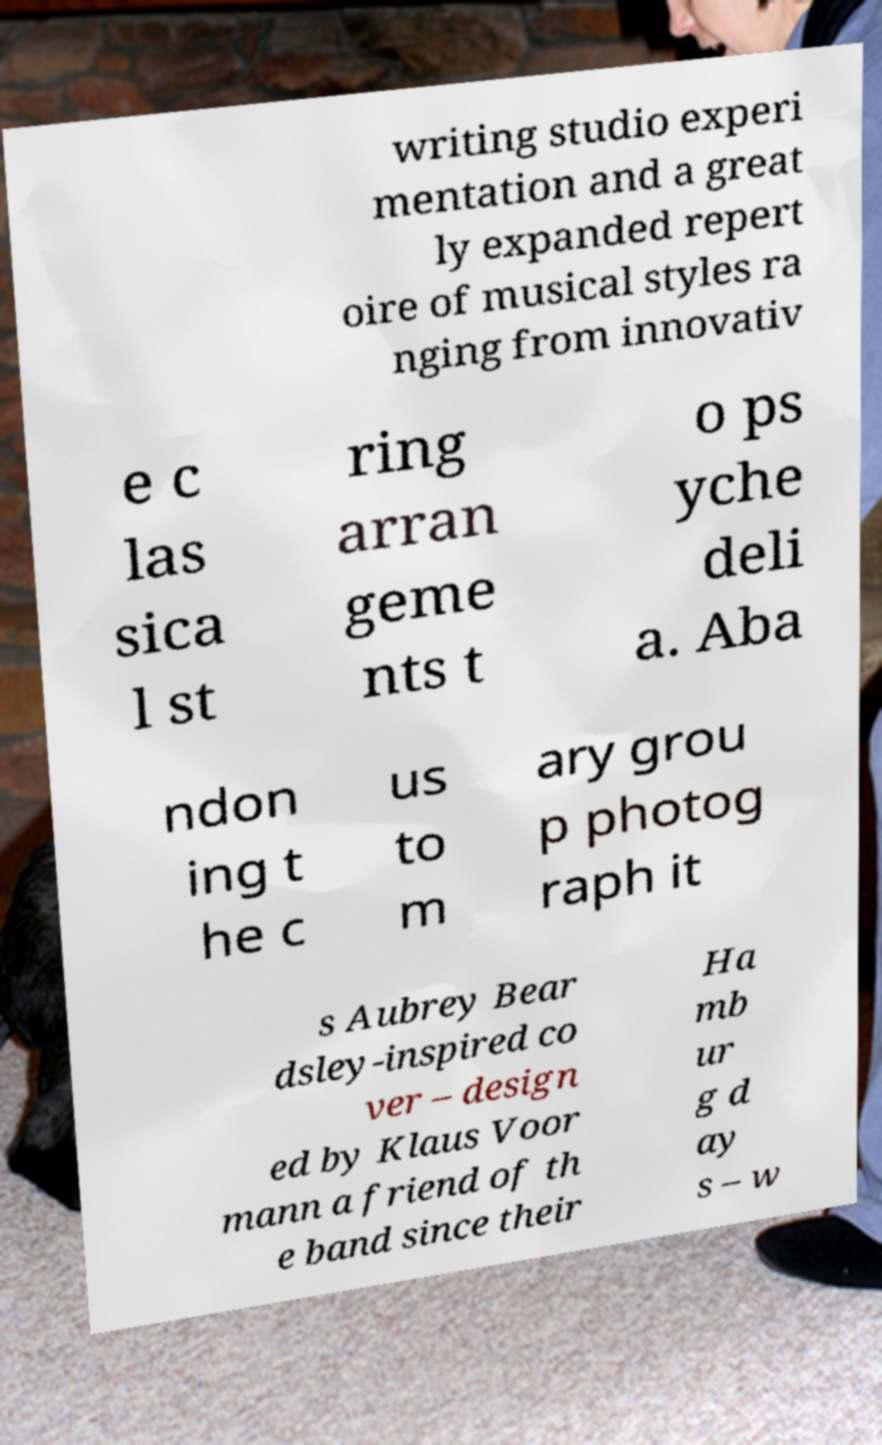Could you extract and type out the text from this image? writing studio experi mentation and a great ly expanded repert oire of musical styles ra nging from innovativ e c las sica l st ring arran geme nts t o ps yche deli a. Aba ndon ing t he c us to m ary grou p photog raph it s Aubrey Bear dsley-inspired co ver – design ed by Klaus Voor mann a friend of th e band since their Ha mb ur g d ay s – w 